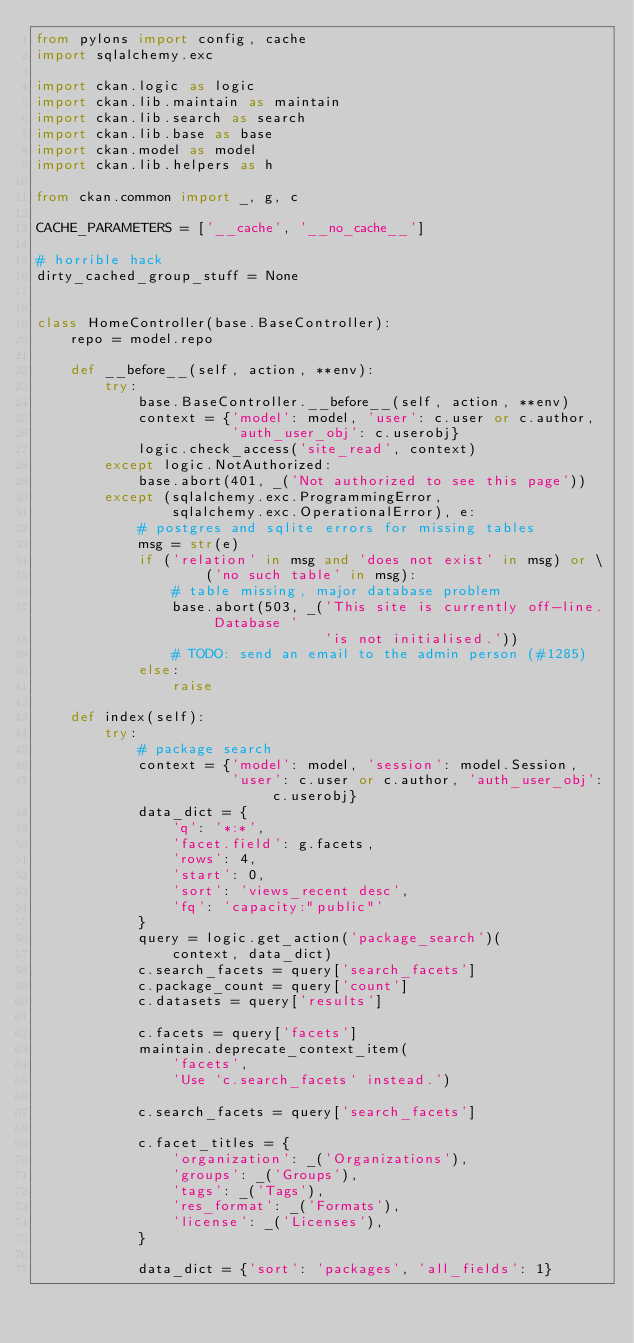Convert code to text. <code><loc_0><loc_0><loc_500><loc_500><_Python_>from pylons import config, cache
import sqlalchemy.exc

import ckan.logic as logic
import ckan.lib.maintain as maintain
import ckan.lib.search as search
import ckan.lib.base as base
import ckan.model as model
import ckan.lib.helpers as h

from ckan.common import _, g, c

CACHE_PARAMETERS = ['__cache', '__no_cache__']

# horrible hack
dirty_cached_group_stuff = None


class HomeController(base.BaseController):
    repo = model.repo

    def __before__(self, action, **env):
        try:
            base.BaseController.__before__(self, action, **env)
            context = {'model': model, 'user': c.user or c.author,
                       'auth_user_obj': c.userobj}
            logic.check_access('site_read', context)
        except logic.NotAuthorized:
            base.abort(401, _('Not authorized to see this page'))
        except (sqlalchemy.exc.ProgrammingError,
                sqlalchemy.exc.OperationalError), e:
            # postgres and sqlite errors for missing tables
            msg = str(e)
            if ('relation' in msg and 'does not exist' in msg) or \
                    ('no such table' in msg):
                # table missing, major database problem
                base.abort(503, _('This site is currently off-line. Database '
                                  'is not initialised.'))
                # TODO: send an email to the admin person (#1285)
            else:
                raise

    def index(self):
        try:
            # package search
            context = {'model': model, 'session': model.Session,
                       'user': c.user or c.author, 'auth_user_obj': c.userobj}
            data_dict = {
                'q': '*:*',
                'facet.field': g.facets,
                'rows': 4,
                'start': 0,
                'sort': 'views_recent desc',
                'fq': 'capacity:"public"'
            }
            query = logic.get_action('package_search')(
                context, data_dict)
            c.search_facets = query['search_facets']
            c.package_count = query['count']
            c.datasets = query['results']

            c.facets = query['facets']
            maintain.deprecate_context_item(
                'facets',
                'Use `c.search_facets` instead.')

            c.search_facets = query['search_facets']

            c.facet_titles = {
                'organization': _('Organizations'),
                'groups': _('Groups'),
                'tags': _('Tags'),
                'res_format': _('Formats'),
                'license': _('Licenses'),
            }

            data_dict = {'sort': 'packages', 'all_fields': 1}</code> 